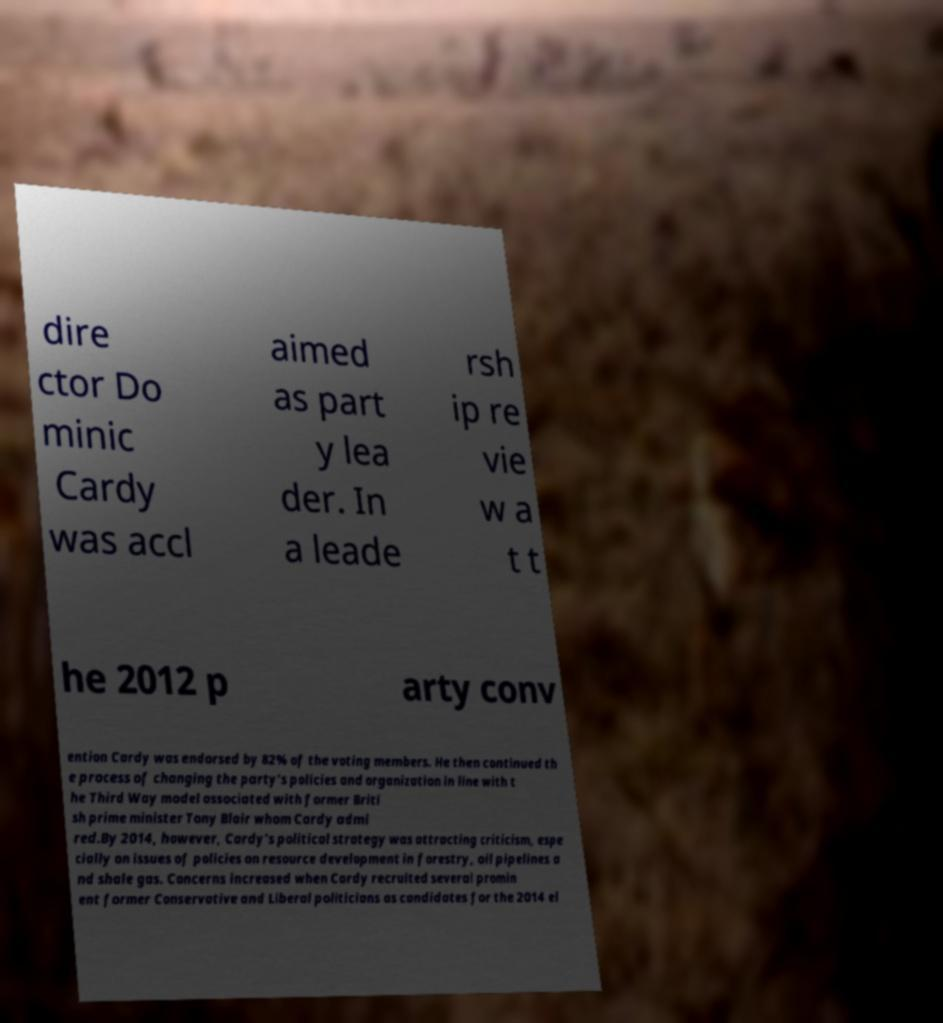I need the written content from this picture converted into text. Can you do that? dire ctor Do minic Cardy was accl aimed as part y lea der. In a leade rsh ip re vie w a t t he 2012 p arty conv ention Cardy was endorsed by 82% of the voting members. He then continued th e process of changing the party's policies and organization in line with t he Third Way model associated with former Briti sh prime minister Tony Blair whom Cardy admi red.By 2014, however, Cardy's political strategy was attracting criticism, espe cially on issues of policies on resource development in forestry, oil pipelines a nd shale gas. Concerns increased when Cardy recruited several promin ent former Conservative and Liberal politicians as candidates for the 2014 el 